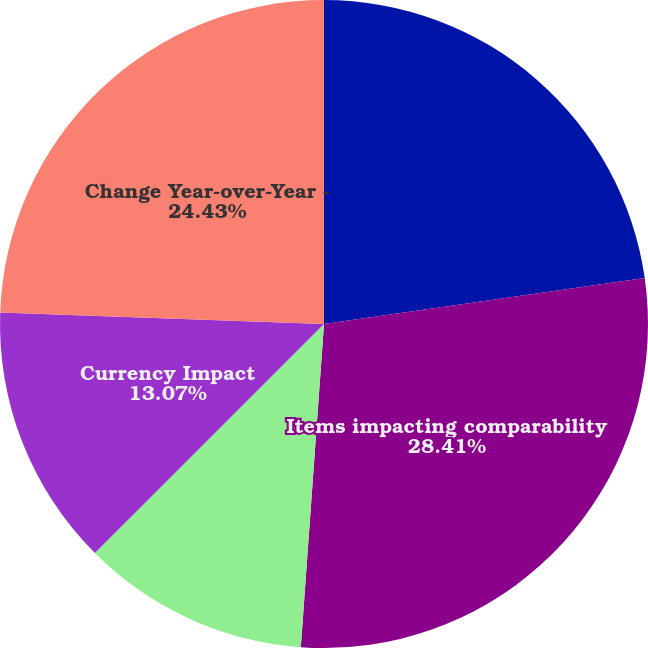<chart> <loc_0><loc_0><loc_500><loc_500><pie_chart><fcel>Change - Reported (GAAP)<fcel>Items impacting comparability<fcel>Change - Adjusted (Non-GAAP)<fcel>Currency Impact<fcel>Change Year-over-Year -<nl><fcel>22.73%<fcel>28.41%<fcel>11.36%<fcel>13.07%<fcel>24.43%<nl></chart> 